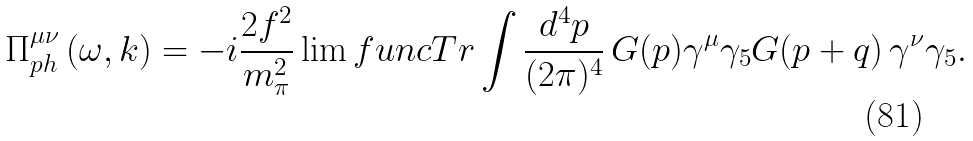Convert formula to latex. <formula><loc_0><loc_0><loc_500><loc_500>\Pi _ { p h } ^ { \mu \nu } \left ( \omega , k \right ) = - i \frac { 2 f ^ { 2 } } { m _ { \pi } ^ { 2 } } \lim f u n c { T r } \int \frac { d ^ { 4 } p } { ( 2 \pi ) ^ { 4 } } \, { G } ( p ) \gamma ^ { \mu } \gamma _ { 5 } { G } ( p + q ) \, \gamma ^ { \nu } \gamma _ { 5 } .</formula> 